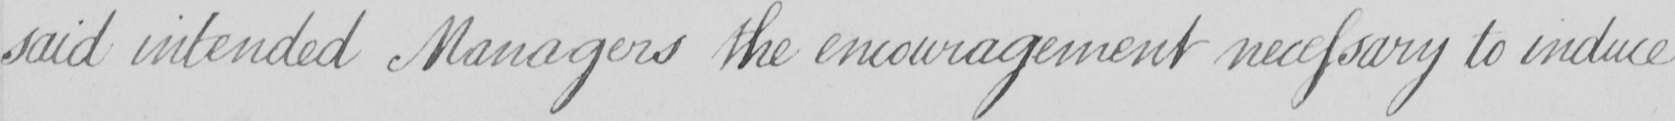Can you tell me what this handwritten text says? said intended Managers the encouragement necessary to induce 